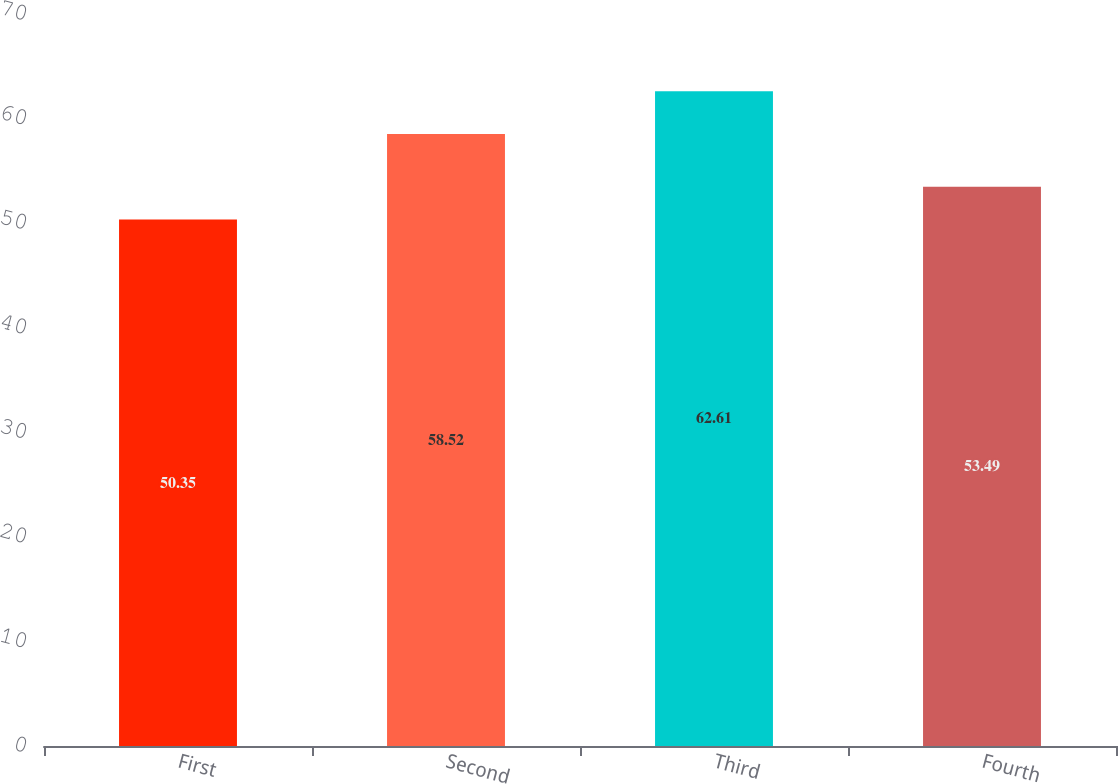<chart> <loc_0><loc_0><loc_500><loc_500><bar_chart><fcel>First<fcel>Second<fcel>Third<fcel>Fourth<nl><fcel>50.35<fcel>58.52<fcel>62.61<fcel>53.49<nl></chart> 